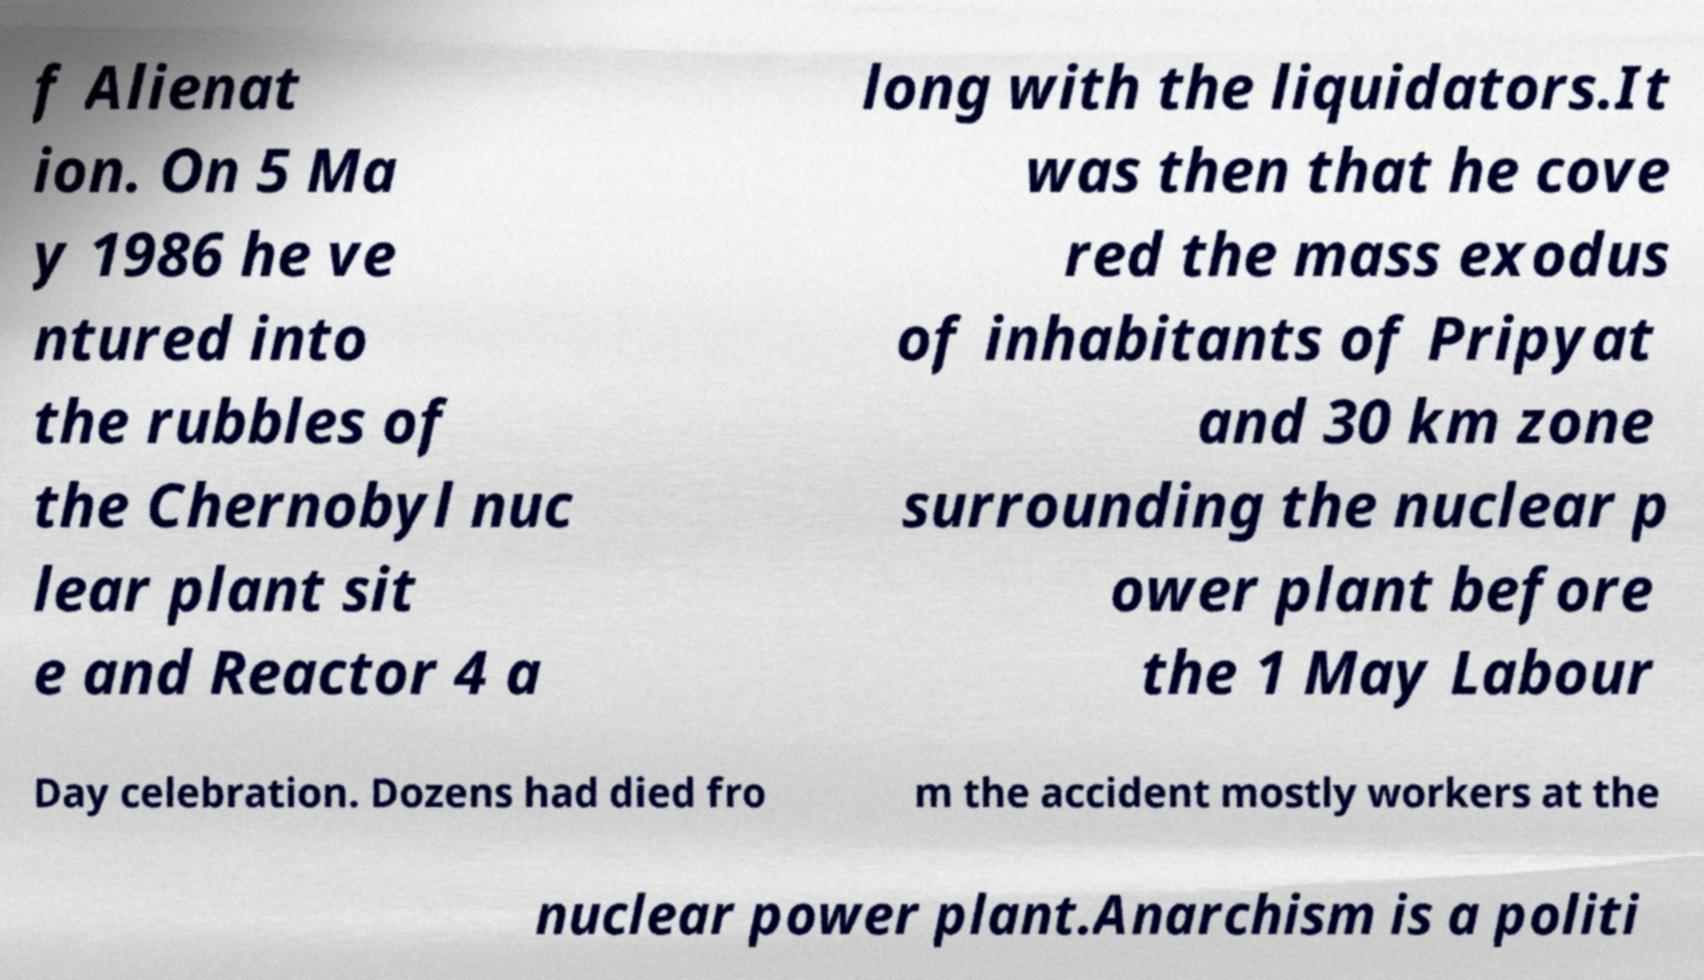What messages or text are displayed in this image? I need them in a readable, typed format. f Alienat ion. On 5 Ma y 1986 he ve ntured into the rubbles of the Chernobyl nuc lear plant sit e and Reactor 4 a long with the liquidators.It was then that he cove red the mass exodus of inhabitants of Pripyat and 30 km zone surrounding the nuclear p ower plant before the 1 May Labour Day celebration. Dozens had died fro m the accident mostly workers at the nuclear power plant.Anarchism is a politi 